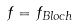<formula> <loc_0><loc_0><loc_500><loc_500>f = f _ { B l o c h }</formula> 